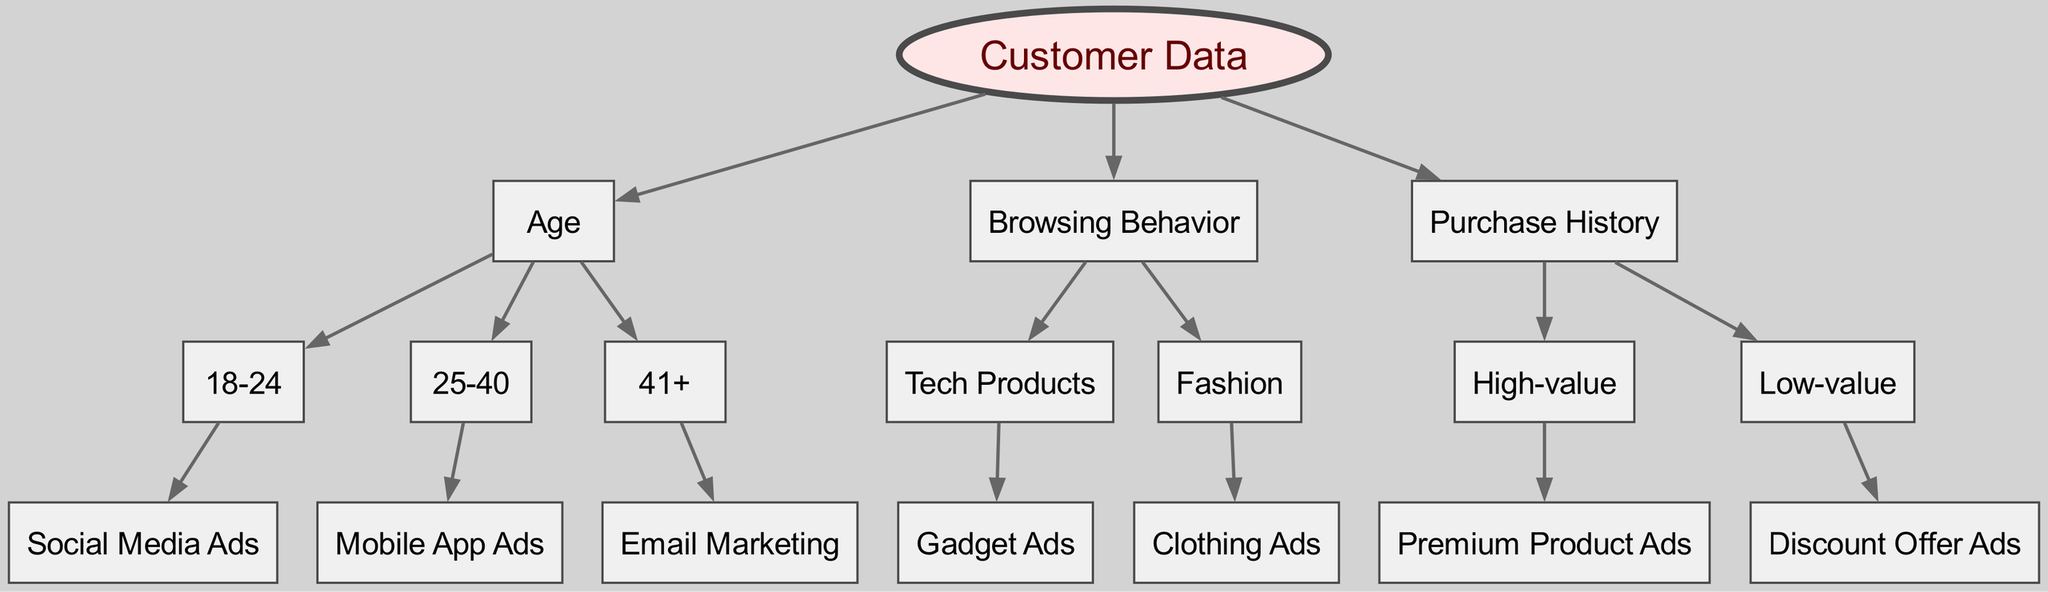What is the root node of the diagram? The root node of the diagram is "Customer Data." It serves as the starting point for the decision tree and branches out into various nodes based on different customer characteristics.
Answer: Customer Data How many main nodes are there under "Customer Data"? There are three main nodes under "Customer Data" which are "Age," "Browsing Behavior," and "Purchase History." These nodes categorize customers based on different attributes.
Answer: 3 What type of ads is targeted at customers aged 18-24? The targeted ads for customers aged 18-24, according to the diagram, are "Social Media Ads." This segment is likely targeted through platforms predominantly used by this age group.
Answer: Social Media Ads What is the segment for "High-value" in the Purchase History node? The segment for "High-value" in the Purchase History node leads to "Premium Product Ads." This indicates that customers who make high-value purchases are targeted with premium products promotional ads.
Answer: Premium Product Ads Which advertising method is linked to browsing behavior involving "Tech Products"? The advertising method linked to browsing behavior involving "Tech Products" is "Gadget Ads." This indicates a focus on specific products appealing to tech-savvy customers.
Answer: Gadget Ads Which age category is associated with "Mobile App Ads"? The age category associated with "Mobile App Ads" is "25-40." This suggests that this demographic is more likely to engage with mobile applications and be targeted through such ads.
Answer: 25-40 Explain the flow from "Browsing Behavior" to the types of ads. What ads come from the "Fashion" browsing behavior? The flow from "Browsing Behavior" first identifies the category of interest, which is "Fashion." From this category, the specific advertising method is "Clothing Ads." The diagram illustrates that customers who exhibit a browsing pattern towards fashion-related content are targeted with ads for clothing products.
Answer: Clothing Ads How many children does the "Age" node have? The "Age" node has three children corresponding to the age ranges "18-24," "25-40," and "41+." Each child represents a distinct segmentation for advertising based on age.
Answer: 3 What is the advertising strategy for customers in the "Low-value" category? The advertising strategy for customers in the "Low-value" category is "Discount Offer Ads." This strategy aims to attract price-sensitive customers through promotional offers.
Answer: Discount Offer Ads 